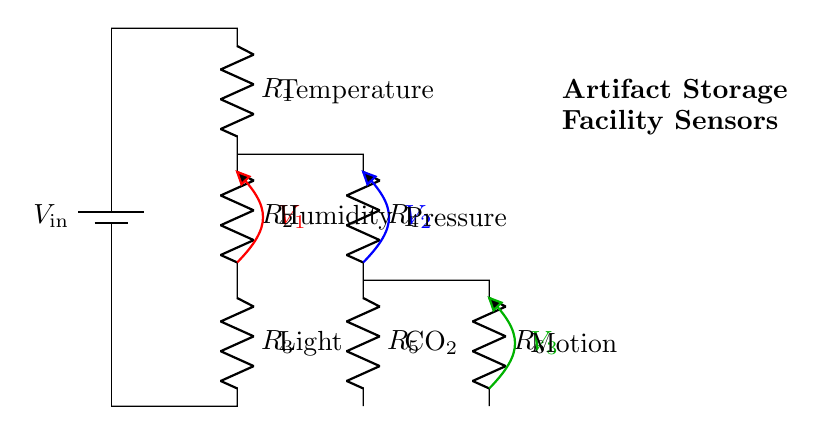What is the input voltage of the circuit? The input voltage is denoted as V_in, which represents the total voltage supplied to the circuit.
Answer: V_in How many resistors are present in the circuit? There are six resistors labeled R1, R2, R3, R4, R5, and R6, making a total of six resistors in the circuit.
Answer: 6 What sensors are connected to the voltage divider? The sensors connected are Temperature, Humidity, Light, Pressure, CO₂, and Motion, indicating a total of six distinct sensors.
Answer: Temperature, Humidity, Light, Pressure, CO₂, Motion What is the voltage across R1? The voltage between R1 and R2 is labeled as V1, which signifies the potential difference across the first resistor in the series.
Answer: V1 Which component has the lowest resistance? The resistors are not quantitatively specified, but based on the arrangement, it can be inferred that typically, R1 would be the one with a lower resistance compared to others in the divider configuration to provide a higher output.
Answer: R1 What is the purpose of the voltage divider in this circuit? The purpose of the voltage divider is to provide different voltage levels to various sensors in the climate-controlled facility, allowing them to operate efficiently at their required voltage levels.
Answer: To power sensors 